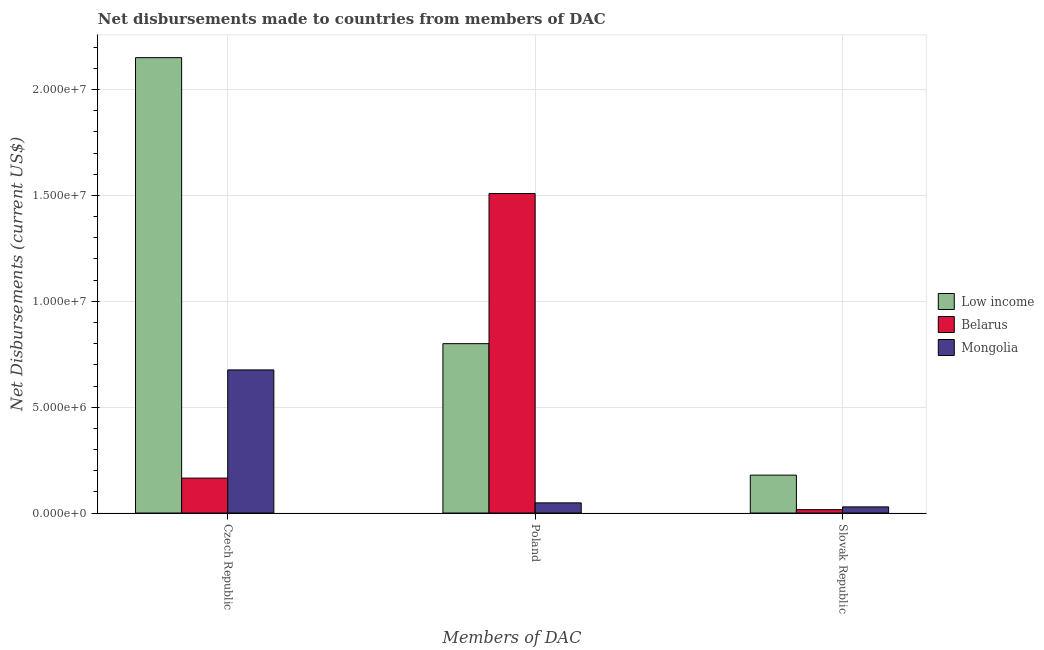How many different coloured bars are there?
Offer a very short reply. 3. How many groups of bars are there?
Offer a terse response. 3. How many bars are there on the 3rd tick from the left?
Your response must be concise. 3. How many bars are there on the 1st tick from the right?
Provide a short and direct response. 3. What is the net disbursements made by poland in Low income?
Keep it short and to the point. 8.00e+06. Across all countries, what is the maximum net disbursements made by czech republic?
Provide a succinct answer. 2.15e+07. Across all countries, what is the minimum net disbursements made by czech republic?
Offer a very short reply. 1.65e+06. In which country was the net disbursements made by czech republic minimum?
Your answer should be compact. Belarus. What is the total net disbursements made by czech republic in the graph?
Offer a very short reply. 2.99e+07. What is the difference between the net disbursements made by poland in Mongolia and that in Belarus?
Your answer should be very brief. -1.46e+07. What is the difference between the net disbursements made by slovak republic in Belarus and the net disbursements made by poland in Low income?
Keep it short and to the point. -7.84e+06. What is the average net disbursements made by poland per country?
Offer a very short reply. 7.86e+06. What is the difference between the net disbursements made by poland and net disbursements made by slovak republic in Mongolia?
Your answer should be very brief. 1.90e+05. What is the ratio of the net disbursements made by poland in Low income to that in Belarus?
Ensure brevity in your answer.  0.53. Is the net disbursements made by czech republic in Mongolia less than that in Belarus?
Give a very brief answer. No. What is the difference between the highest and the second highest net disbursements made by poland?
Your answer should be compact. 7.09e+06. What is the difference between the highest and the lowest net disbursements made by slovak republic?
Provide a succinct answer. 1.63e+06. In how many countries, is the net disbursements made by czech republic greater than the average net disbursements made by czech republic taken over all countries?
Offer a very short reply. 1. Is the sum of the net disbursements made by czech republic in Belarus and Low income greater than the maximum net disbursements made by poland across all countries?
Ensure brevity in your answer.  Yes. What does the 1st bar from the right in Czech Republic represents?
Your answer should be very brief. Mongolia. Are all the bars in the graph horizontal?
Offer a terse response. No. How many countries are there in the graph?
Your answer should be very brief. 3. What is the difference between two consecutive major ticks on the Y-axis?
Provide a succinct answer. 5.00e+06. Does the graph contain grids?
Keep it short and to the point. Yes. Where does the legend appear in the graph?
Give a very brief answer. Center right. How are the legend labels stacked?
Your answer should be very brief. Vertical. What is the title of the graph?
Your answer should be very brief. Net disbursements made to countries from members of DAC. What is the label or title of the X-axis?
Make the answer very short. Members of DAC. What is the label or title of the Y-axis?
Make the answer very short. Net Disbursements (current US$). What is the Net Disbursements (current US$) in Low income in Czech Republic?
Ensure brevity in your answer.  2.15e+07. What is the Net Disbursements (current US$) in Belarus in Czech Republic?
Your answer should be very brief. 1.65e+06. What is the Net Disbursements (current US$) in Mongolia in Czech Republic?
Provide a succinct answer. 6.76e+06. What is the Net Disbursements (current US$) of Belarus in Poland?
Offer a very short reply. 1.51e+07. What is the Net Disbursements (current US$) of Mongolia in Poland?
Offer a very short reply. 4.80e+05. What is the Net Disbursements (current US$) of Low income in Slovak Republic?
Your answer should be compact. 1.79e+06. What is the Net Disbursements (current US$) in Belarus in Slovak Republic?
Your answer should be very brief. 1.60e+05. What is the Net Disbursements (current US$) in Mongolia in Slovak Republic?
Make the answer very short. 2.90e+05. Across all Members of DAC, what is the maximum Net Disbursements (current US$) of Low income?
Offer a very short reply. 2.15e+07. Across all Members of DAC, what is the maximum Net Disbursements (current US$) in Belarus?
Keep it short and to the point. 1.51e+07. Across all Members of DAC, what is the maximum Net Disbursements (current US$) in Mongolia?
Provide a short and direct response. 6.76e+06. Across all Members of DAC, what is the minimum Net Disbursements (current US$) in Low income?
Provide a succinct answer. 1.79e+06. Across all Members of DAC, what is the minimum Net Disbursements (current US$) in Belarus?
Your answer should be compact. 1.60e+05. What is the total Net Disbursements (current US$) in Low income in the graph?
Give a very brief answer. 3.13e+07. What is the total Net Disbursements (current US$) in Belarus in the graph?
Offer a very short reply. 1.69e+07. What is the total Net Disbursements (current US$) of Mongolia in the graph?
Give a very brief answer. 7.53e+06. What is the difference between the Net Disbursements (current US$) in Low income in Czech Republic and that in Poland?
Give a very brief answer. 1.35e+07. What is the difference between the Net Disbursements (current US$) of Belarus in Czech Republic and that in Poland?
Keep it short and to the point. -1.34e+07. What is the difference between the Net Disbursements (current US$) in Mongolia in Czech Republic and that in Poland?
Ensure brevity in your answer.  6.28e+06. What is the difference between the Net Disbursements (current US$) in Low income in Czech Republic and that in Slovak Republic?
Provide a succinct answer. 1.97e+07. What is the difference between the Net Disbursements (current US$) in Belarus in Czech Republic and that in Slovak Republic?
Give a very brief answer. 1.49e+06. What is the difference between the Net Disbursements (current US$) of Mongolia in Czech Republic and that in Slovak Republic?
Offer a very short reply. 6.47e+06. What is the difference between the Net Disbursements (current US$) of Low income in Poland and that in Slovak Republic?
Give a very brief answer. 6.21e+06. What is the difference between the Net Disbursements (current US$) in Belarus in Poland and that in Slovak Republic?
Keep it short and to the point. 1.49e+07. What is the difference between the Net Disbursements (current US$) in Low income in Czech Republic and the Net Disbursements (current US$) in Belarus in Poland?
Offer a very short reply. 6.42e+06. What is the difference between the Net Disbursements (current US$) of Low income in Czech Republic and the Net Disbursements (current US$) of Mongolia in Poland?
Provide a succinct answer. 2.10e+07. What is the difference between the Net Disbursements (current US$) of Belarus in Czech Republic and the Net Disbursements (current US$) of Mongolia in Poland?
Keep it short and to the point. 1.17e+06. What is the difference between the Net Disbursements (current US$) in Low income in Czech Republic and the Net Disbursements (current US$) in Belarus in Slovak Republic?
Provide a succinct answer. 2.14e+07. What is the difference between the Net Disbursements (current US$) in Low income in Czech Republic and the Net Disbursements (current US$) in Mongolia in Slovak Republic?
Your response must be concise. 2.12e+07. What is the difference between the Net Disbursements (current US$) in Belarus in Czech Republic and the Net Disbursements (current US$) in Mongolia in Slovak Republic?
Give a very brief answer. 1.36e+06. What is the difference between the Net Disbursements (current US$) of Low income in Poland and the Net Disbursements (current US$) of Belarus in Slovak Republic?
Offer a terse response. 7.84e+06. What is the difference between the Net Disbursements (current US$) of Low income in Poland and the Net Disbursements (current US$) of Mongolia in Slovak Republic?
Your response must be concise. 7.71e+06. What is the difference between the Net Disbursements (current US$) of Belarus in Poland and the Net Disbursements (current US$) of Mongolia in Slovak Republic?
Offer a terse response. 1.48e+07. What is the average Net Disbursements (current US$) in Low income per Members of DAC?
Make the answer very short. 1.04e+07. What is the average Net Disbursements (current US$) of Belarus per Members of DAC?
Your answer should be compact. 5.63e+06. What is the average Net Disbursements (current US$) in Mongolia per Members of DAC?
Provide a short and direct response. 2.51e+06. What is the difference between the Net Disbursements (current US$) in Low income and Net Disbursements (current US$) in Belarus in Czech Republic?
Offer a very short reply. 1.99e+07. What is the difference between the Net Disbursements (current US$) in Low income and Net Disbursements (current US$) in Mongolia in Czech Republic?
Offer a very short reply. 1.48e+07. What is the difference between the Net Disbursements (current US$) of Belarus and Net Disbursements (current US$) of Mongolia in Czech Republic?
Give a very brief answer. -5.11e+06. What is the difference between the Net Disbursements (current US$) in Low income and Net Disbursements (current US$) in Belarus in Poland?
Your answer should be compact. -7.09e+06. What is the difference between the Net Disbursements (current US$) in Low income and Net Disbursements (current US$) in Mongolia in Poland?
Make the answer very short. 7.52e+06. What is the difference between the Net Disbursements (current US$) in Belarus and Net Disbursements (current US$) in Mongolia in Poland?
Ensure brevity in your answer.  1.46e+07. What is the difference between the Net Disbursements (current US$) in Low income and Net Disbursements (current US$) in Belarus in Slovak Republic?
Give a very brief answer. 1.63e+06. What is the difference between the Net Disbursements (current US$) of Low income and Net Disbursements (current US$) of Mongolia in Slovak Republic?
Your answer should be very brief. 1.50e+06. What is the ratio of the Net Disbursements (current US$) of Low income in Czech Republic to that in Poland?
Ensure brevity in your answer.  2.69. What is the ratio of the Net Disbursements (current US$) of Belarus in Czech Republic to that in Poland?
Offer a terse response. 0.11. What is the ratio of the Net Disbursements (current US$) of Mongolia in Czech Republic to that in Poland?
Offer a very short reply. 14.08. What is the ratio of the Net Disbursements (current US$) in Low income in Czech Republic to that in Slovak Republic?
Your response must be concise. 12.02. What is the ratio of the Net Disbursements (current US$) of Belarus in Czech Republic to that in Slovak Republic?
Ensure brevity in your answer.  10.31. What is the ratio of the Net Disbursements (current US$) in Mongolia in Czech Republic to that in Slovak Republic?
Provide a short and direct response. 23.31. What is the ratio of the Net Disbursements (current US$) in Low income in Poland to that in Slovak Republic?
Make the answer very short. 4.47. What is the ratio of the Net Disbursements (current US$) in Belarus in Poland to that in Slovak Republic?
Your answer should be very brief. 94.31. What is the ratio of the Net Disbursements (current US$) of Mongolia in Poland to that in Slovak Republic?
Keep it short and to the point. 1.66. What is the difference between the highest and the second highest Net Disbursements (current US$) of Low income?
Ensure brevity in your answer.  1.35e+07. What is the difference between the highest and the second highest Net Disbursements (current US$) in Belarus?
Offer a very short reply. 1.34e+07. What is the difference between the highest and the second highest Net Disbursements (current US$) of Mongolia?
Your answer should be compact. 6.28e+06. What is the difference between the highest and the lowest Net Disbursements (current US$) in Low income?
Offer a very short reply. 1.97e+07. What is the difference between the highest and the lowest Net Disbursements (current US$) in Belarus?
Your response must be concise. 1.49e+07. What is the difference between the highest and the lowest Net Disbursements (current US$) of Mongolia?
Your answer should be very brief. 6.47e+06. 